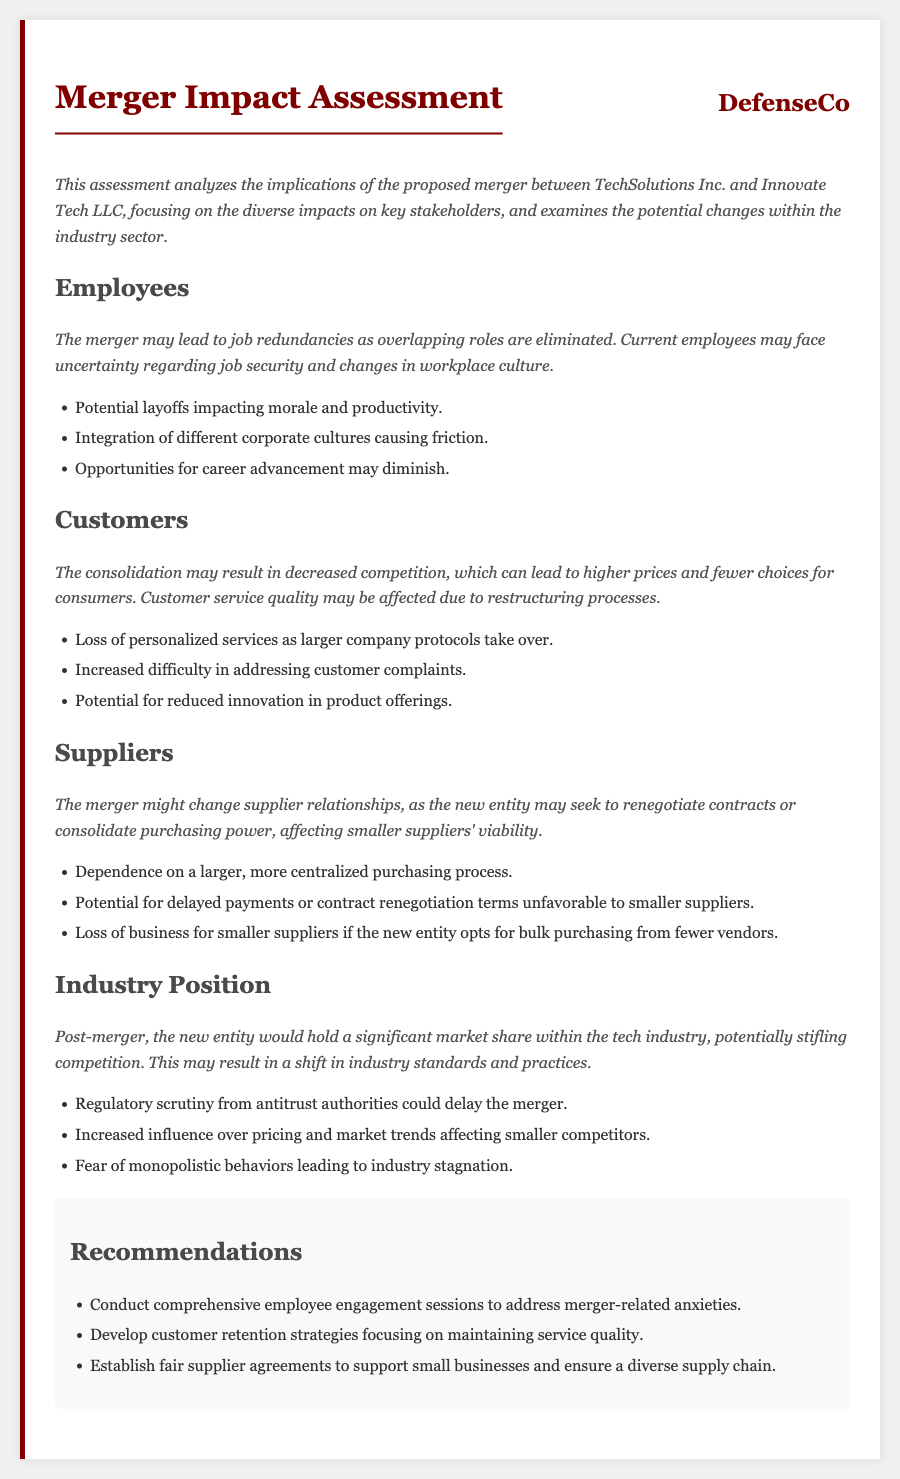what is the focus of the assessment? The assessment focuses on the implications of the proposed merger on key stakeholders and potential changes within the industry sector.
Answer: implications of the proposed merger what are the potential impacts on employees? The potential impacts on employees include job redundancies, uncertainty regarding job security, and changes in workplace culture.
Answer: job redundancies what may happen to customers post-merger? Post-merger, customers may experience decreased competition, leading to higher prices and fewer choices.
Answer: decreased competition what is one impact on suppliers mentioned in the document? The document mentions that the merger might change supplier relationships, possibly affecting smaller suppliers' viability.
Answer: smaller suppliers' viability how might the merger affect the industry position? The new entity would hold a significant market share, potentially stifling competition and shifting industry standards.
Answer: significant market share what type of scrutiny could the merger face? The merger could face regulatory scrutiny from antitrust authorities, which might delay the merger.
Answer: regulatory scrutiny what recommendation is given for employees? One recommendation is to conduct comprehensive employee engagement sessions to address merger-related anxieties.
Answer: employee engagement sessions what is a potential consequence of the merger for innovation? The merger may lead to a potential for reduced innovation in product offerings.
Answer: reduced innovation 